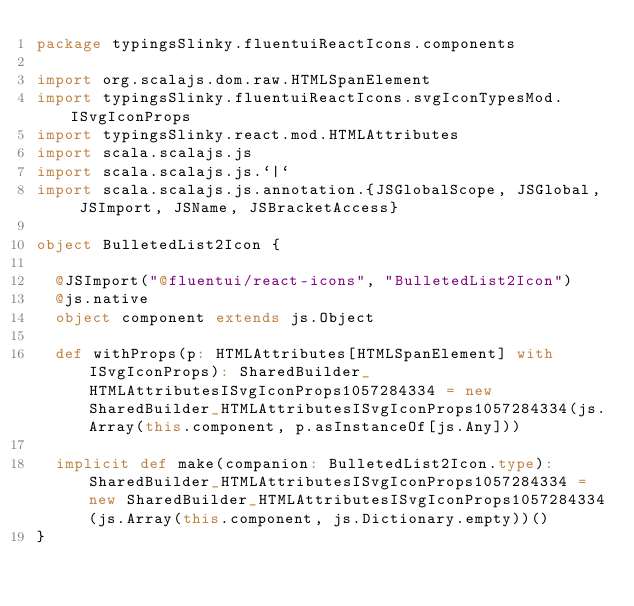Convert code to text. <code><loc_0><loc_0><loc_500><loc_500><_Scala_>package typingsSlinky.fluentuiReactIcons.components

import org.scalajs.dom.raw.HTMLSpanElement
import typingsSlinky.fluentuiReactIcons.svgIconTypesMod.ISvgIconProps
import typingsSlinky.react.mod.HTMLAttributes
import scala.scalajs.js
import scala.scalajs.js.`|`
import scala.scalajs.js.annotation.{JSGlobalScope, JSGlobal, JSImport, JSName, JSBracketAccess}

object BulletedList2Icon {
  
  @JSImport("@fluentui/react-icons", "BulletedList2Icon")
  @js.native
  object component extends js.Object
  
  def withProps(p: HTMLAttributes[HTMLSpanElement] with ISvgIconProps): SharedBuilder_HTMLAttributesISvgIconProps1057284334 = new SharedBuilder_HTMLAttributesISvgIconProps1057284334(js.Array(this.component, p.asInstanceOf[js.Any]))
  
  implicit def make(companion: BulletedList2Icon.type): SharedBuilder_HTMLAttributesISvgIconProps1057284334 = new SharedBuilder_HTMLAttributesISvgIconProps1057284334(js.Array(this.component, js.Dictionary.empty))()
}
</code> 